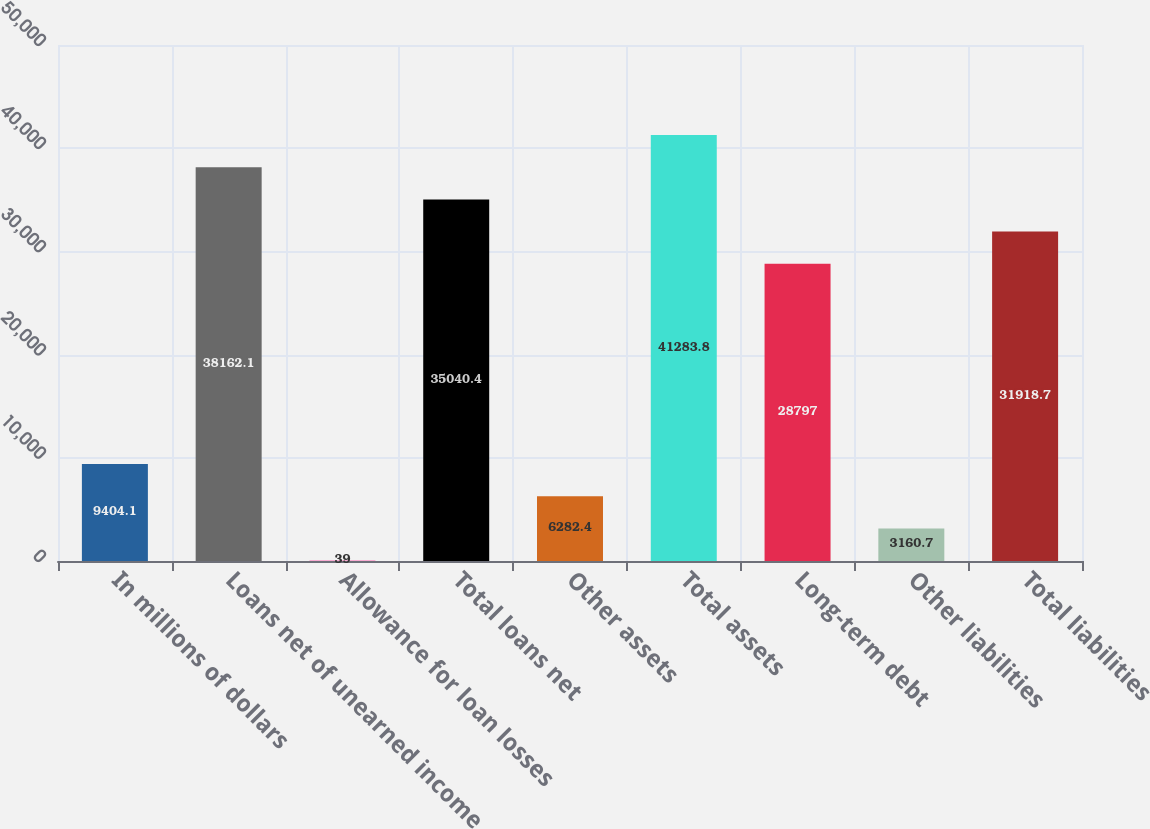<chart> <loc_0><loc_0><loc_500><loc_500><bar_chart><fcel>In millions of dollars<fcel>Loans net of unearned income<fcel>Allowance for loan losses<fcel>Total loans net<fcel>Other assets<fcel>Total assets<fcel>Long-term debt<fcel>Other liabilities<fcel>Total liabilities<nl><fcel>9404.1<fcel>38162.1<fcel>39<fcel>35040.4<fcel>6282.4<fcel>41283.8<fcel>28797<fcel>3160.7<fcel>31918.7<nl></chart> 